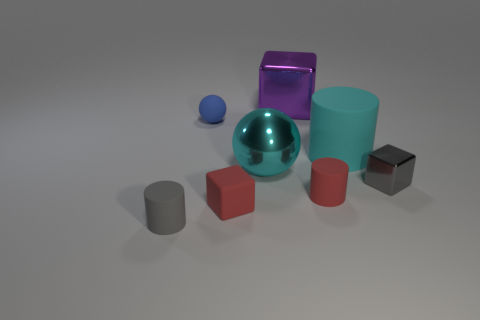There is a gray thing left of the blue object; does it have the same shape as the tiny blue rubber object?
Your answer should be very brief. No. Is the number of small things in front of the big cylinder greater than the number of small gray metal things that are behind the tiny rubber ball?
Make the answer very short. Yes. How many things have the same material as the tiny gray block?
Ensure brevity in your answer.  2. Is the size of the blue object the same as the purple shiny object?
Offer a very short reply. No. The small ball is what color?
Your answer should be compact. Blue. How many things are either gray matte cylinders or tiny brown metallic balls?
Your answer should be compact. 1. Is there another big cyan rubber thing that has the same shape as the cyan rubber object?
Offer a very short reply. No. There is a small matte cylinder right of the purple shiny cube; does it have the same color as the small matte block?
Your response must be concise. Yes. There is a small rubber object that is behind the tiny object that is right of the cyan rubber cylinder; what shape is it?
Make the answer very short. Sphere. Is there a red matte cylinder of the same size as the purple cube?
Give a very brief answer. No. 